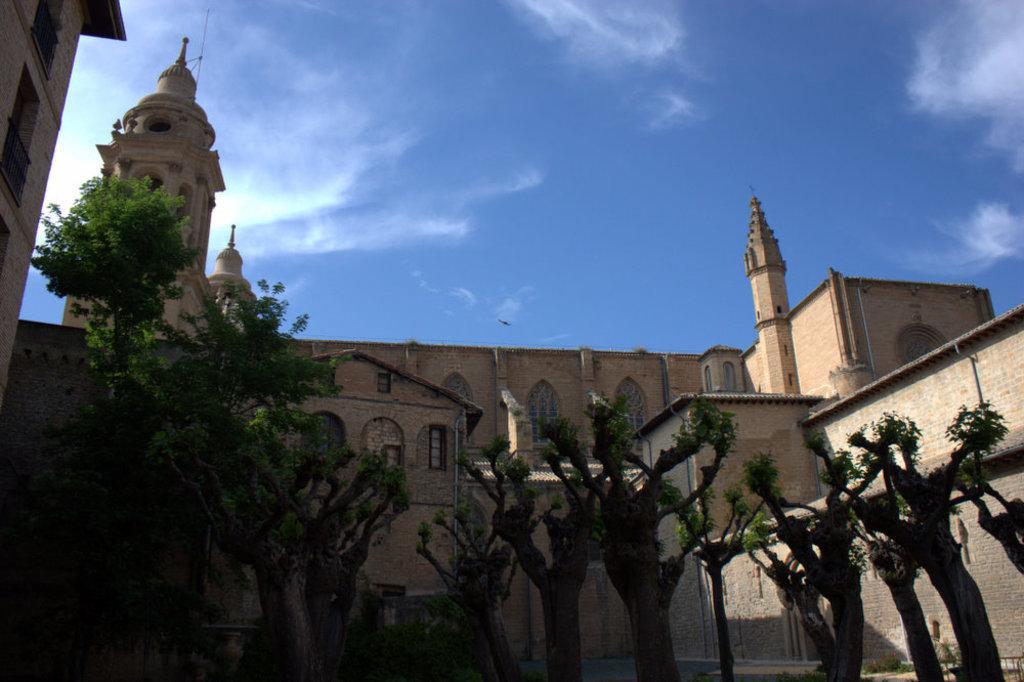Can you describe this image briefly? In this image we can see many trees. Behind the trees we can see the building. At the top there is sky with some clouds. 